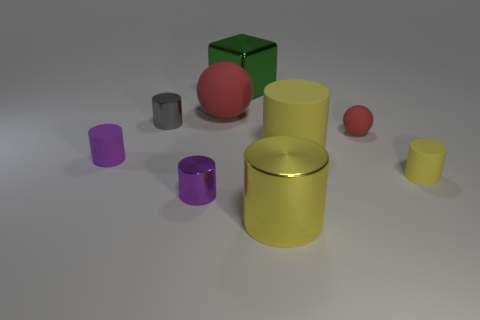Subtract all blue cubes. How many yellow cylinders are left? 3 Subtract all gray cylinders. How many cylinders are left? 5 Subtract all tiny purple shiny cylinders. How many cylinders are left? 5 Subtract 1 cylinders. How many cylinders are left? 5 Subtract all gray cylinders. Subtract all gray spheres. How many cylinders are left? 5 Add 1 small spheres. How many objects exist? 10 Subtract all blocks. How many objects are left? 8 Subtract all large green metal blocks. Subtract all large matte cylinders. How many objects are left? 7 Add 4 purple things. How many purple things are left? 6 Add 7 brown metallic objects. How many brown metallic objects exist? 7 